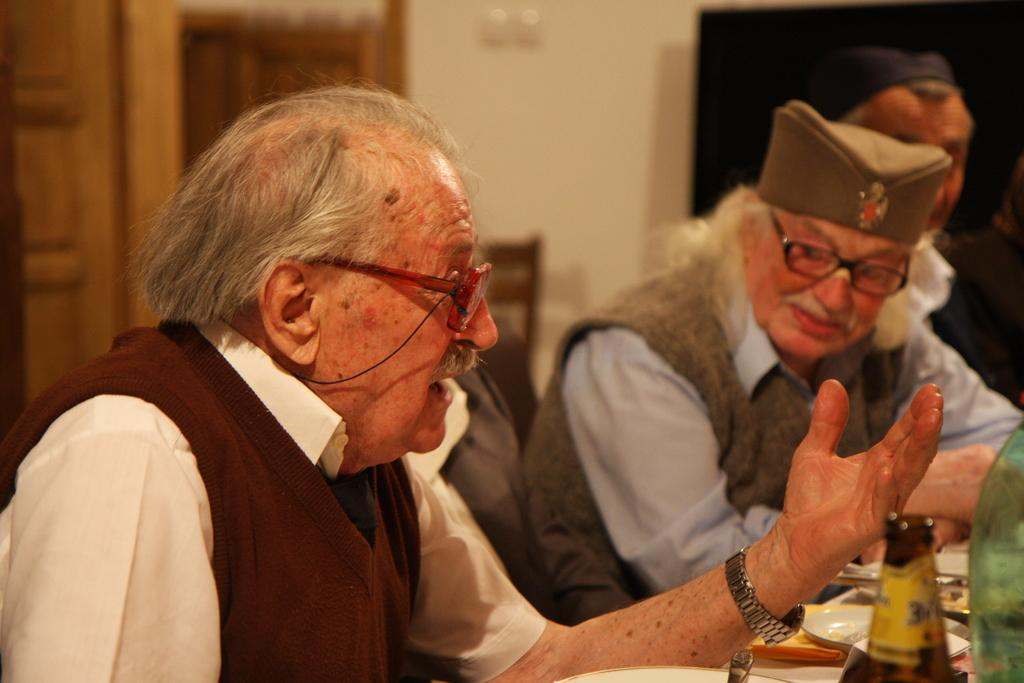How many people are in the image? There are three men in the image. What are the men doing in the image? The men are sitting on chairs. What is in front of the men? There is a table in front of the men. What can be seen on the table? There are plates and bottles on the table. Can you describe the background of the image? The background of the image is blurred. What type of sidewalk can be seen in the image? There is no sidewalk present in the image. Can you tell me how many cars are parked behind the men in the image? There are no cars visible in the image; the background is blurred. 